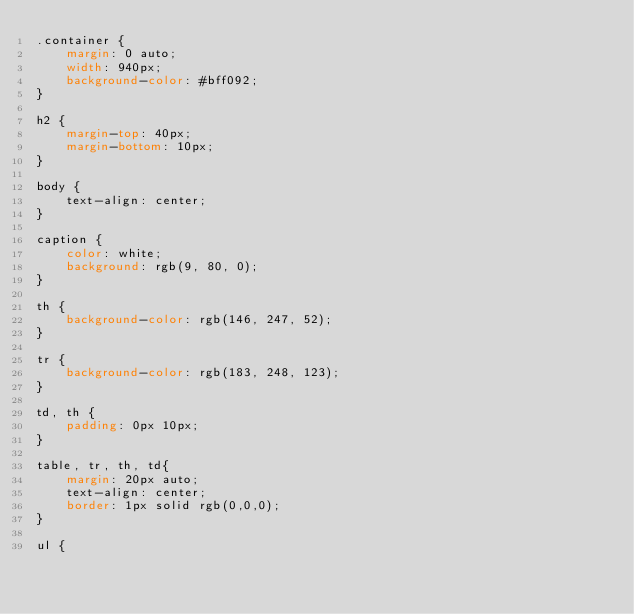Convert code to text. <code><loc_0><loc_0><loc_500><loc_500><_CSS_>.container {
    margin: 0 auto;
    width: 940px;
    background-color: #bff092;
}

h2 {
    margin-top: 40px;
    margin-bottom: 10px;
}

body {
    text-align: center;
}

caption {
    color: white;
    background: rgb(9, 80, 0);
}

th {
    background-color: rgb(146, 247, 52);
}

tr {
    background-color: rgb(183, 248, 123);
}

td, th {
    padding: 0px 10px;
}

table, tr, th, td{
    margin: 20px auto;
    text-align: center;
    border: 1px solid rgb(0,0,0);
}

ul {</code> 